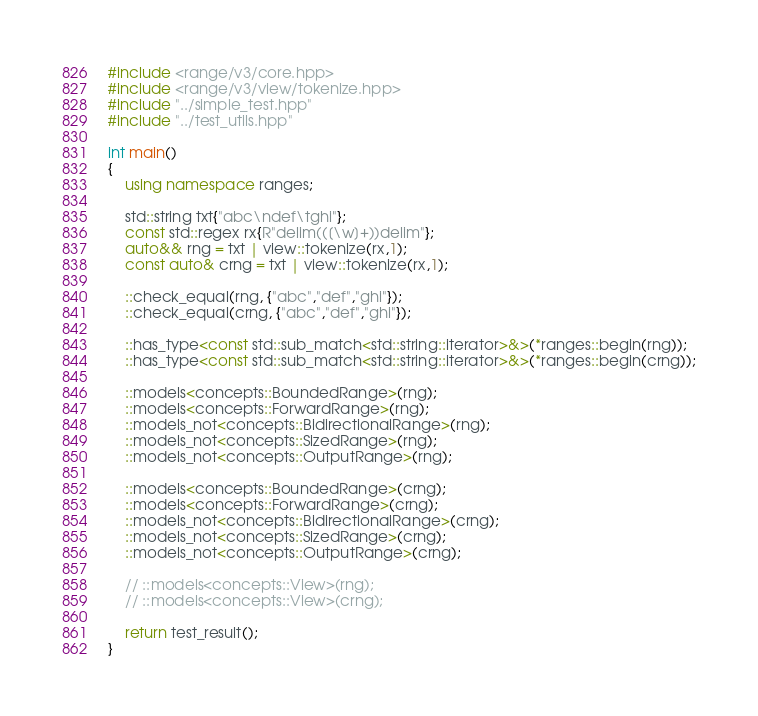Convert code to text. <code><loc_0><loc_0><loc_500><loc_500><_C++_>#include <range/v3/core.hpp>
#include <range/v3/view/tokenize.hpp>
#include "../simple_test.hpp"
#include "../test_utils.hpp"

int main()
{
    using namespace ranges;

    std::string txt{"abc\ndef\tghi"};
    const std::regex rx{R"delim(([\w]+))delim"};
    auto&& rng = txt | view::tokenize(rx,1);
    const auto& crng = txt | view::tokenize(rx,1);

    ::check_equal(rng, {"abc","def","ghi"});
    ::check_equal(crng, {"abc","def","ghi"});

    ::has_type<const std::sub_match<std::string::iterator>&>(*ranges::begin(rng));
    ::has_type<const std::sub_match<std::string::iterator>&>(*ranges::begin(crng));

    ::models<concepts::BoundedRange>(rng);
    ::models<concepts::ForwardRange>(rng);
    ::models_not<concepts::BidirectionalRange>(rng);
    ::models_not<concepts::SizedRange>(rng);
    ::models_not<concepts::OutputRange>(rng);

    ::models<concepts::BoundedRange>(crng);
    ::models<concepts::ForwardRange>(crng);
    ::models_not<concepts::BidirectionalRange>(crng);
    ::models_not<concepts::SizedRange>(crng);
    ::models_not<concepts::OutputRange>(crng);

    // ::models<concepts::View>(rng);
    // ::models<concepts::View>(crng);

    return test_result();
}
</code> 